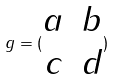<formula> <loc_0><loc_0><loc_500><loc_500>g = ( \begin{matrix} a & b \\ c & d \end{matrix} )</formula> 